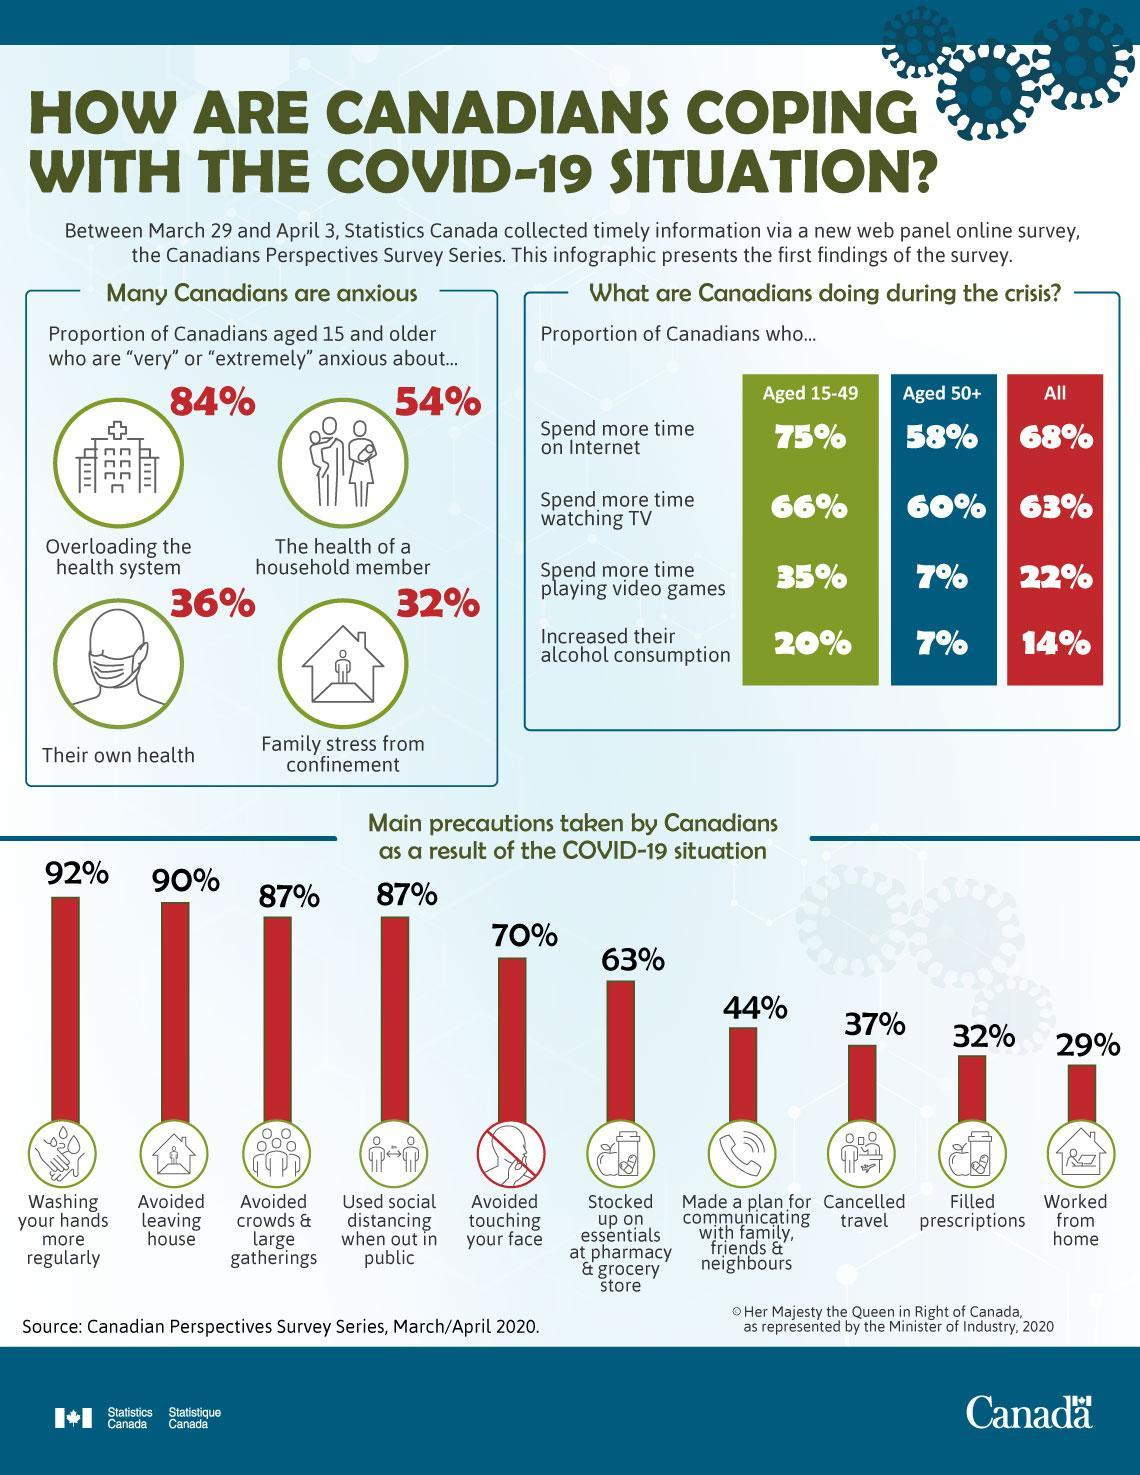What percent of Canadians aged 50+ years increased their alcohol consumption during the COVID-19 period as per the survey?
Answer the question with a short phrase. 7% What percent of Canadians aged 15 years & older are extremely anxious about their own health during the COVID-19 period according to the survey? 36% What percent of Canadians aged 15-49 years spend more time playing videos during the COVID-19 period as per the survey? 35% What percent of Canadians worked from home as a result of COVID-19 situation? 29% What percent of Canadians aged 50+ years spend more time watching TV during the COVID-19 period as per the survey? 60% What percent of Canadians avoided leaving house as a result of COVID-19 situation? 90% What percent of Canadians aged 15 years & older are very anxious about the health of a household member during the COVID-19 period according to the survey? 54% What percent of Canadians aged 15 years & older are very anxious about the family stress from confinement during the COVID-19 period according to the survey? 32% What percent of Canadians cancelled travel as a result of COVID-19 situation? 37% What percent of Canadians spend more time on internet during the COVID-19 period as per the survey? 68% 